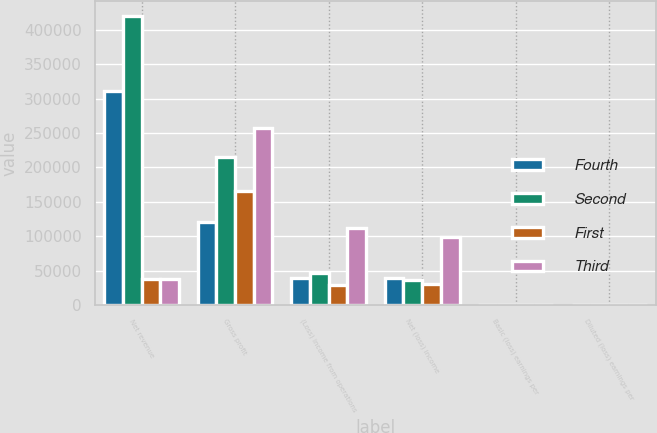Convert chart to OTSL. <chart><loc_0><loc_0><loc_500><loc_500><stacked_bar_chart><ecel><fcel>Net revenue<fcel>Gross profit<fcel>(Loss) income from operations<fcel>Net (loss) income<fcel>Basic (loss) earnings per<fcel>Diluted (loss) earnings per<nl><fcel>Fourth<fcel>311552<fcel>120171<fcel>38983<fcel>38567<fcel>0.46<fcel>0.46<nl><fcel>Second<fcel>420167<fcel>214562<fcel>47194<fcel>36432<fcel>0.42<fcel>0.39<nl><fcel>First<fcel>37499.5<fcel>165399<fcel>28409<fcel>29842<fcel>0.33<fcel>0.33<nl><fcel>Third<fcel>37499.5<fcel>256657<fcel>111503<fcel>99280<fcel>0.97<fcel>0.89<nl></chart> 